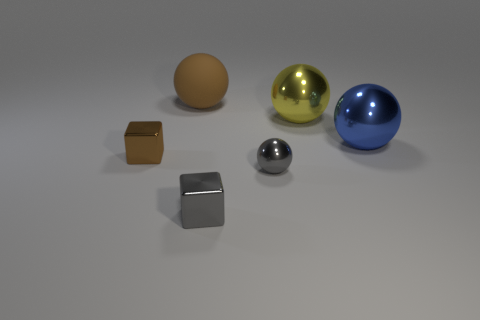Can you describe the texture of the smallest object in the image? The smallest object, which is a silver metallic sphere, appears to have a smooth and reflective texture. Its surface likely feels cool to the touch and mirrors the environment, as characteristic of polished metal. 